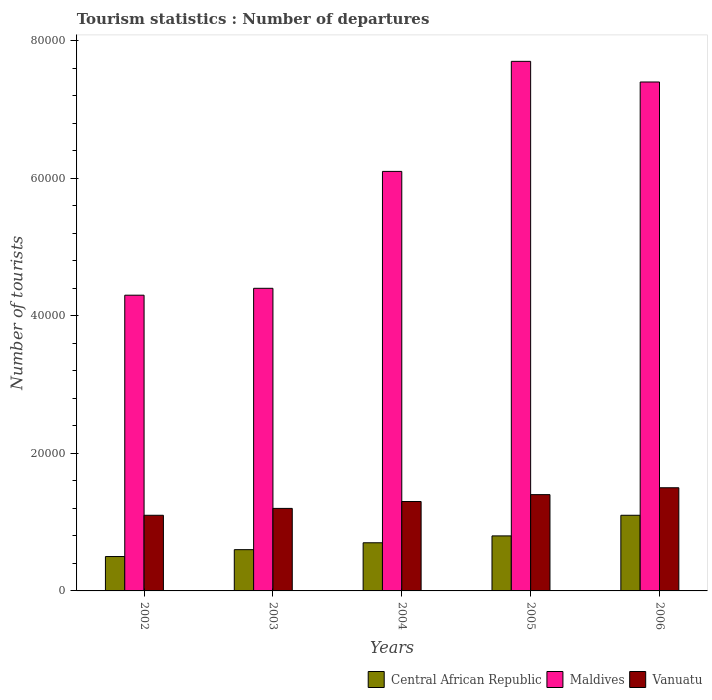Are the number of bars on each tick of the X-axis equal?
Make the answer very short. Yes. How many bars are there on the 4th tick from the right?
Offer a very short reply. 3. In how many cases, is the number of bars for a given year not equal to the number of legend labels?
Your response must be concise. 0. Across all years, what is the maximum number of tourist departures in Central African Republic?
Your answer should be very brief. 1.10e+04. Across all years, what is the minimum number of tourist departures in Maldives?
Make the answer very short. 4.30e+04. In which year was the number of tourist departures in Vanuatu minimum?
Your response must be concise. 2002. What is the total number of tourist departures in Vanuatu in the graph?
Provide a succinct answer. 6.50e+04. What is the difference between the number of tourist departures in Maldives in 2002 and that in 2006?
Provide a short and direct response. -3.10e+04. What is the difference between the number of tourist departures in Central African Republic in 2003 and the number of tourist departures in Vanuatu in 2002?
Your answer should be compact. -5000. What is the average number of tourist departures in Central African Republic per year?
Make the answer very short. 7400. In the year 2004, what is the difference between the number of tourist departures in Vanuatu and number of tourist departures in Maldives?
Offer a very short reply. -4.80e+04. What is the ratio of the number of tourist departures in Maldives in 2003 to that in 2004?
Your answer should be compact. 0.72. Is the difference between the number of tourist departures in Vanuatu in 2003 and 2006 greater than the difference between the number of tourist departures in Maldives in 2003 and 2006?
Make the answer very short. Yes. What is the difference between the highest and the second highest number of tourist departures in Maldives?
Your answer should be very brief. 3000. What is the difference between the highest and the lowest number of tourist departures in Maldives?
Your answer should be very brief. 3.40e+04. Is the sum of the number of tourist departures in Vanuatu in 2004 and 2006 greater than the maximum number of tourist departures in Central African Republic across all years?
Give a very brief answer. Yes. What does the 3rd bar from the left in 2006 represents?
Your answer should be very brief. Vanuatu. What does the 2nd bar from the right in 2005 represents?
Offer a terse response. Maldives. Is it the case that in every year, the sum of the number of tourist departures in Maldives and number of tourist departures in Vanuatu is greater than the number of tourist departures in Central African Republic?
Ensure brevity in your answer.  Yes. Are all the bars in the graph horizontal?
Keep it short and to the point. No. Are the values on the major ticks of Y-axis written in scientific E-notation?
Your response must be concise. No. Does the graph contain any zero values?
Your answer should be very brief. No. Does the graph contain grids?
Keep it short and to the point. No. How many legend labels are there?
Offer a very short reply. 3. How are the legend labels stacked?
Provide a succinct answer. Horizontal. What is the title of the graph?
Ensure brevity in your answer.  Tourism statistics : Number of departures. What is the label or title of the X-axis?
Make the answer very short. Years. What is the label or title of the Y-axis?
Ensure brevity in your answer.  Number of tourists. What is the Number of tourists of Maldives in 2002?
Provide a short and direct response. 4.30e+04. What is the Number of tourists in Vanuatu in 2002?
Your answer should be very brief. 1.10e+04. What is the Number of tourists of Central African Republic in 2003?
Keep it short and to the point. 6000. What is the Number of tourists of Maldives in 2003?
Make the answer very short. 4.40e+04. What is the Number of tourists of Vanuatu in 2003?
Make the answer very short. 1.20e+04. What is the Number of tourists in Central African Republic in 2004?
Give a very brief answer. 7000. What is the Number of tourists of Maldives in 2004?
Give a very brief answer. 6.10e+04. What is the Number of tourists in Vanuatu in 2004?
Provide a short and direct response. 1.30e+04. What is the Number of tourists of Central African Republic in 2005?
Offer a very short reply. 8000. What is the Number of tourists of Maldives in 2005?
Keep it short and to the point. 7.70e+04. What is the Number of tourists in Vanuatu in 2005?
Your answer should be compact. 1.40e+04. What is the Number of tourists in Central African Republic in 2006?
Keep it short and to the point. 1.10e+04. What is the Number of tourists in Maldives in 2006?
Make the answer very short. 7.40e+04. What is the Number of tourists in Vanuatu in 2006?
Provide a succinct answer. 1.50e+04. Across all years, what is the maximum Number of tourists of Central African Republic?
Keep it short and to the point. 1.10e+04. Across all years, what is the maximum Number of tourists of Maldives?
Your answer should be very brief. 7.70e+04. Across all years, what is the maximum Number of tourists in Vanuatu?
Make the answer very short. 1.50e+04. Across all years, what is the minimum Number of tourists of Central African Republic?
Keep it short and to the point. 5000. Across all years, what is the minimum Number of tourists in Maldives?
Ensure brevity in your answer.  4.30e+04. Across all years, what is the minimum Number of tourists in Vanuatu?
Keep it short and to the point. 1.10e+04. What is the total Number of tourists in Central African Republic in the graph?
Offer a terse response. 3.70e+04. What is the total Number of tourists in Maldives in the graph?
Provide a short and direct response. 2.99e+05. What is the total Number of tourists of Vanuatu in the graph?
Provide a succinct answer. 6.50e+04. What is the difference between the Number of tourists in Central African Republic in 2002 and that in 2003?
Offer a very short reply. -1000. What is the difference between the Number of tourists of Maldives in 2002 and that in 2003?
Ensure brevity in your answer.  -1000. What is the difference between the Number of tourists of Vanuatu in 2002 and that in 2003?
Make the answer very short. -1000. What is the difference between the Number of tourists in Central African Republic in 2002 and that in 2004?
Provide a succinct answer. -2000. What is the difference between the Number of tourists of Maldives in 2002 and that in 2004?
Provide a short and direct response. -1.80e+04. What is the difference between the Number of tourists in Vanuatu in 2002 and that in 2004?
Offer a very short reply. -2000. What is the difference between the Number of tourists in Central African Republic in 2002 and that in 2005?
Provide a short and direct response. -3000. What is the difference between the Number of tourists of Maldives in 2002 and that in 2005?
Make the answer very short. -3.40e+04. What is the difference between the Number of tourists in Vanuatu in 2002 and that in 2005?
Provide a succinct answer. -3000. What is the difference between the Number of tourists of Central African Republic in 2002 and that in 2006?
Ensure brevity in your answer.  -6000. What is the difference between the Number of tourists in Maldives in 2002 and that in 2006?
Provide a succinct answer. -3.10e+04. What is the difference between the Number of tourists of Vanuatu in 2002 and that in 2006?
Ensure brevity in your answer.  -4000. What is the difference between the Number of tourists in Central African Republic in 2003 and that in 2004?
Offer a terse response. -1000. What is the difference between the Number of tourists in Maldives in 2003 and that in 2004?
Provide a succinct answer. -1.70e+04. What is the difference between the Number of tourists in Vanuatu in 2003 and that in 2004?
Give a very brief answer. -1000. What is the difference between the Number of tourists in Central African Republic in 2003 and that in 2005?
Offer a very short reply. -2000. What is the difference between the Number of tourists in Maldives in 2003 and that in 2005?
Ensure brevity in your answer.  -3.30e+04. What is the difference between the Number of tourists of Vanuatu in 2003 and that in 2005?
Provide a short and direct response. -2000. What is the difference between the Number of tourists in Central African Republic in 2003 and that in 2006?
Offer a very short reply. -5000. What is the difference between the Number of tourists in Maldives in 2003 and that in 2006?
Keep it short and to the point. -3.00e+04. What is the difference between the Number of tourists of Vanuatu in 2003 and that in 2006?
Ensure brevity in your answer.  -3000. What is the difference between the Number of tourists of Central African Republic in 2004 and that in 2005?
Ensure brevity in your answer.  -1000. What is the difference between the Number of tourists in Maldives in 2004 and that in 2005?
Your answer should be very brief. -1.60e+04. What is the difference between the Number of tourists in Vanuatu in 2004 and that in 2005?
Offer a very short reply. -1000. What is the difference between the Number of tourists of Central African Republic in 2004 and that in 2006?
Provide a short and direct response. -4000. What is the difference between the Number of tourists in Maldives in 2004 and that in 2006?
Offer a terse response. -1.30e+04. What is the difference between the Number of tourists in Vanuatu in 2004 and that in 2006?
Ensure brevity in your answer.  -2000. What is the difference between the Number of tourists in Central African Republic in 2005 and that in 2006?
Give a very brief answer. -3000. What is the difference between the Number of tourists in Maldives in 2005 and that in 2006?
Provide a short and direct response. 3000. What is the difference between the Number of tourists of Vanuatu in 2005 and that in 2006?
Ensure brevity in your answer.  -1000. What is the difference between the Number of tourists in Central African Republic in 2002 and the Number of tourists in Maldives in 2003?
Provide a short and direct response. -3.90e+04. What is the difference between the Number of tourists of Central African Republic in 2002 and the Number of tourists of Vanuatu in 2003?
Your answer should be compact. -7000. What is the difference between the Number of tourists of Maldives in 2002 and the Number of tourists of Vanuatu in 2003?
Provide a short and direct response. 3.10e+04. What is the difference between the Number of tourists in Central African Republic in 2002 and the Number of tourists in Maldives in 2004?
Ensure brevity in your answer.  -5.60e+04. What is the difference between the Number of tourists of Central African Republic in 2002 and the Number of tourists of Vanuatu in 2004?
Offer a terse response. -8000. What is the difference between the Number of tourists of Central African Republic in 2002 and the Number of tourists of Maldives in 2005?
Provide a short and direct response. -7.20e+04. What is the difference between the Number of tourists of Central African Republic in 2002 and the Number of tourists of Vanuatu in 2005?
Your answer should be compact. -9000. What is the difference between the Number of tourists in Maldives in 2002 and the Number of tourists in Vanuatu in 2005?
Offer a very short reply. 2.90e+04. What is the difference between the Number of tourists of Central African Republic in 2002 and the Number of tourists of Maldives in 2006?
Keep it short and to the point. -6.90e+04. What is the difference between the Number of tourists of Central African Republic in 2002 and the Number of tourists of Vanuatu in 2006?
Provide a succinct answer. -10000. What is the difference between the Number of tourists of Maldives in 2002 and the Number of tourists of Vanuatu in 2006?
Your answer should be very brief. 2.80e+04. What is the difference between the Number of tourists in Central African Republic in 2003 and the Number of tourists in Maldives in 2004?
Your answer should be very brief. -5.50e+04. What is the difference between the Number of tourists of Central African Republic in 2003 and the Number of tourists of Vanuatu in 2004?
Your answer should be very brief. -7000. What is the difference between the Number of tourists in Maldives in 2003 and the Number of tourists in Vanuatu in 2004?
Ensure brevity in your answer.  3.10e+04. What is the difference between the Number of tourists in Central African Republic in 2003 and the Number of tourists in Maldives in 2005?
Ensure brevity in your answer.  -7.10e+04. What is the difference between the Number of tourists of Central African Republic in 2003 and the Number of tourists of Vanuatu in 2005?
Ensure brevity in your answer.  -8000. What is the difference between the Number of tourists in Central African Republic in 2003 and the Number of tourists in Maldives in 2006?
Offer a terse response. -6.80e+04. What is the difference between the Number of tourists of Central African Republic in 2003 and the Number of tourists of Vanuatu in 2006?
Offer a very short reply. -9000. What is the difference between the Number of tourists of Maldives in 2003 and the Number of tourists of Vanuatu in 2006?
Provide a succinct answer. 2.90e+04. What is the difference between the Number of tourists in Central African Republic in 2004 and the Number of tourists in Maldives in 2005?
Provide a succinct answer. -7.00e+04. What is the difference between the Number of tourists of Central African Republic in 2004 and the Number of tourists of Vanuatu in 2005?
Ensure brevity in your answer.  -7000. What is the difference between the Number of tourists of Maldives in 2004 and the Number of tourists of Vanuatu in 2005?
Give a very brief answer. 4.70e+04. What is the difference between the Number of tourists of Central African Republic in 2004 and the Number of tourists of Maldives in 2006?
Your answer should be compact. -6.70e+04. What is the difference between the Number of tourists in Central African Republic in 2004 and the Number of tourists in Vanuatu in 2006?
Ensure brevity in your answer.  -8000. What is the difference between the Number of tourists in Maldives in 2004 and the Number of tourists in Vanuatu in 2006?
Make the answer very short. 4.60e+04. What is the difference between the Number of tourists in Central African Republic in 2005 and the Number of tourists in Maldives in 2006?
Your response must be concise. -6.60e+04. What is the difference between the Number of tourists of Central African Republic in 2005 and the Number of tourists of Vanuatu in 2006?
Ensure brevity in your answer.  -7000. What is the difference between the Number of tourists of Maldives in 2005 and the Number of tourists of Vanuatu in 2006?
Your response must be concise. 6.20e+04. What is the average Number of tourists in Central African Republic per year?
Provide a short and direct response. 7400. What is the average Number of tourists in Maldives per year?
Your response must be concise. 5.98e+04. What is the average Number of tourists of Vanuatu per year?
Your answer should be very brief. 1.30e+04. In the year 2002, what is the difference between the Number of tourists in Central African Republic and Number of tourists in Maldives?
Offer a very short reply. -3.80e+04. In the year 2002, what is the difference between the Number of tourists of Central African Republic and Number of tourists of Vanuatu?
Offer a very short reply. -6000. In the year 2002, what is the difference between the Number of tourists in Maldives and Number of tourists in Vanuatu?
Keep it short and to the point. 3.20e+04. In the year 2003, what is the difference between the Number of tourists in Central African Republic and Number of tourists in Maldives?
Your answer should be compact. -3.80e+04. In the year 2003, what is the difference between the Number of tourists in Central African Republic and Number of tourists in Vanuatu?
Provide a succinct answer. -6000. In the year 2003, what is the difference between the Number of tourists in Maldives and Number of tourists in Vanuatu?
Your answer should be compact. 3.20e+04. In the year 2004, what is the difference between the Number of tourists of Central African Republic and Number of tourists of Maldives?
Ensure brevity in your answer.  -5.40e+04. In the year 2004, what is the difference between the Number of tourists in Central African Republic and Number of tourists in Vanuatu?
Your response must be concise. -6000. In the year 2004, what is the difference between the Number of tourists in Maldives and Number of tourists in Vanuatu?
Make the answer very short. 4.80e+04. In the year 2005, what is the difference between the Number of tourists in Central African Republic and Number of tourists in Maldives?
Provide a short and direct response. -6.90e+04. In the year 2005, what is the difference between the Number of tourists in Central African Republic and Number of tourists in Vanuatu?
Your answer should be very brief. -6000. In the year 2005, what is the difference between the Number of tourists of Maldives and Number of tourists of Vanuatu?
Your answer should be very brief. 6.30e+04. In the year 2006, what is the difference between the Number of tourists of Central African Republic and Number of tourists of Maldives?
Offer a terse response. -6.30e+04. In the year 2006, what is the difference between the Number of tourists of Central African Republic and Number of tourists of Vanuatu?
Your answer should be very brief. -4000. In the year 2006, what is the difference between the Number of tourists of Maldives and Number of tourists of Vanuatu?
Provide a short and direct response. 5.90e+04. What is the ratio of the Number of tourists in Central African Republic in 2002 to that in 2003?
Provide a short and direct response. 0.83. What is the ratio of the Number of tourists of Maldives in 2002 to that in 2003?
Keep it short and to the point. 0.98. What is the ratio of the Number of tourists of Vanuatu in 2002 to that in 2003?
Ensure brevity in your answer.  0.92. What is the ratio of the Number of tourists of Central African Republic in 2002 to that in 2004?
Provide a short and direct response. 0.71. What is the ratio of the Number of tourists in Maldives in 2002 to that in 2004?
Make the answer very short. 0.7. What is the ratio of the Number of tourists of Vanuatu in 2002 to that in 2004?
Your response must be concise. 0.85. What is the ratio of the Number of tourists of Maldives in 2002 to that in 2005?
Your answer should be very brief. 0.56. What is the ratio of the Number of tourists of Vanuatu in 2002 to that in 2005?
Your answer should be very brief. 0.79. What is the ratio of the Number of tourists in Central African Republic in 2002 to that in 2006?
Your answer should be compact. 0.45. What is the ratio of the Number of tourists in Maldives in 2002 to that in 2006?
Keep it short and to the point. 0.58. What is the ratio of the Number of tourists of Vanuatu in 2002 to that in 2006?
Keep it short and to the point. 0.73. What is the ratio of the Number of tourists in Central African Republic in 2003 to that in 2004?
Offer a terse response. 0.86. What is the ratio of the Number of tourists in Maldives in 2003 to that in 2004?
Offer a very short reply. 0.72. What is the ratio of the Number of tourists in Central African Republic in 2003 to that in 2005?
Keep it short and to the point. 0.75. What is the ratio of the Number of tourists in Maldives in 2003 to that in 2005?
Offer a terse response. 0.57. What is the ratio of the Number of tourists of Central African Republic in 2003 to that in 2006?
Your answer should be compact. 0.55. What is the ratio of the Number of tourists of Maldives in 2003 to that in 2006?
Provide a succinct answer. 0.59. What is the ratio of the Number of tourists of Vanuatu in 2003 to that in 2006?
Your answer should be very brief. 0.8. What is the ratio of the Number of tourists of Central African Republic in 2004 to that in 2005?
Provide a succinct answer. 0.88. What is the ratio of the Number of tourists of Maldives in 2004 to that in 2005?
Provide a succinct answer. 0.79. What is the ratio of the Number of tourists of Central African Republic in 2004 to that in 2006?
Provide a short and direct response. 0.64. What is the ratio of the Number of tourists of Maldives in 2004 to that in 2006?
Ensure brevity in your answer.  0.82. What is the ratio of the Number of tourists in Vanuatu in 2004 to that in 2006?
Offer a very short reply. 0.87. What is the ratio of the Number of tourists in Central African Republic in 2005 to that in 2006?
Provide a succinct answer. 0.73. What is the ratio of the Number of tourists in Maldives in 2005 to that in 2006?
Keep it short and to the point. 1.04. What is the ratio of the Number of tourists of Vanuatu in 2005 to that in 2006?
Give a very brief answer. 0.93. What is the difference between the highest and the second highest Number of tourists in Central African Republic?
Your answer should be very brief. 3000. What is the difference between the highest and the second highest Number of tourists in Maldives?
Your response must be concise. 3000. What is the difference between the highest and the second highest Number of tourists in Vanuatu?
Make the answer very short. 1000. What is the difference between the highest and the lowest Number of tourists in Central African Republic?
Your response must be concise. 6000. What is the difference between the highest and the lowest Number of tourists in Maldives?
Make the answer very short. 3.40e+04. What is the difference between the highest and the lowest Number of tourists in Vanuatu?
Provide a succinct answer. 4000. 